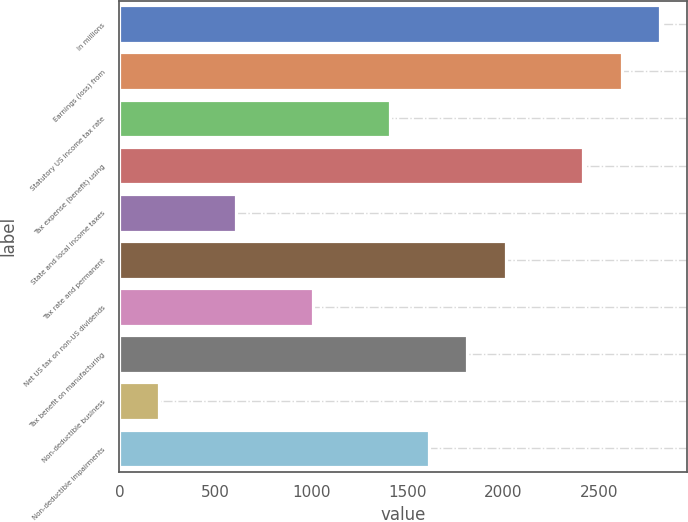Convert chart. <chart><loc_0><loc_0><loc_500><loc_500><bar_chart><fcel>In millions<fcel>Earnings (loss) from<fcel>Statutory US income tax rate<fcel>Tax expense (benefit) using<fcel>State and local income taxes<fcel>Tax rate and permanent<fcel>Net US tax on non-US dividends<fcel>Tax benefit on manufacturing<fcel>Non-deductible business<fcel>Non-deductible impairments<nl><fcel>2817.6<fcel>2616.7<fcel>1411.3<fcel>2415.8<fcel>607.7<fcel>2014<fcel>1009.5<fcel>1813.1<fcel>205.9<fcel>1612.2<nl></chart> 